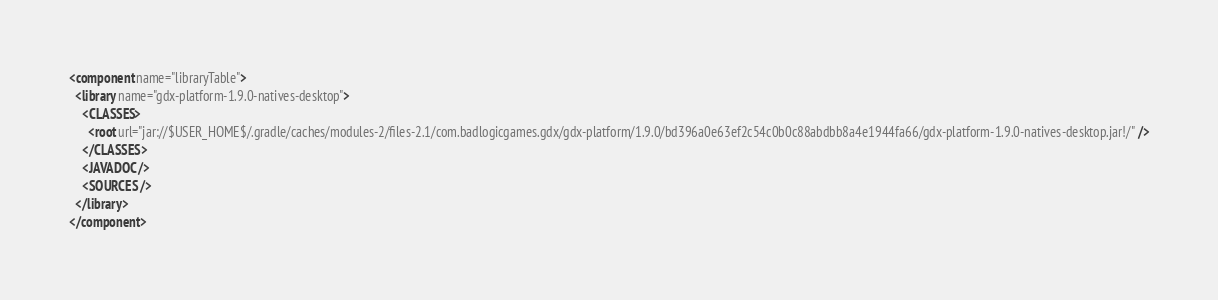Convert code to text. <code><loc_0><loc_0><loc_500><loc_500><_XML_><component name="libraryTable">
  <library name="gdx-platform-1.9.0-natives-desktop">
    <CLASSES>
      <root url="jar://$USER_HOME$/.gradle/caches/modules-2/files-2.1/com.badlogicgames.gdx/gdx-platform/1.9.0/bd396a0e63ef2c54c0b0c88abdbb8a4e1944fa66/gdx-platform-1.9.0-natives-desktop.jar!/" />
    </CLASSES>
    <JAVADOC />
    <SOURCES />
  </library>
</component></code> 